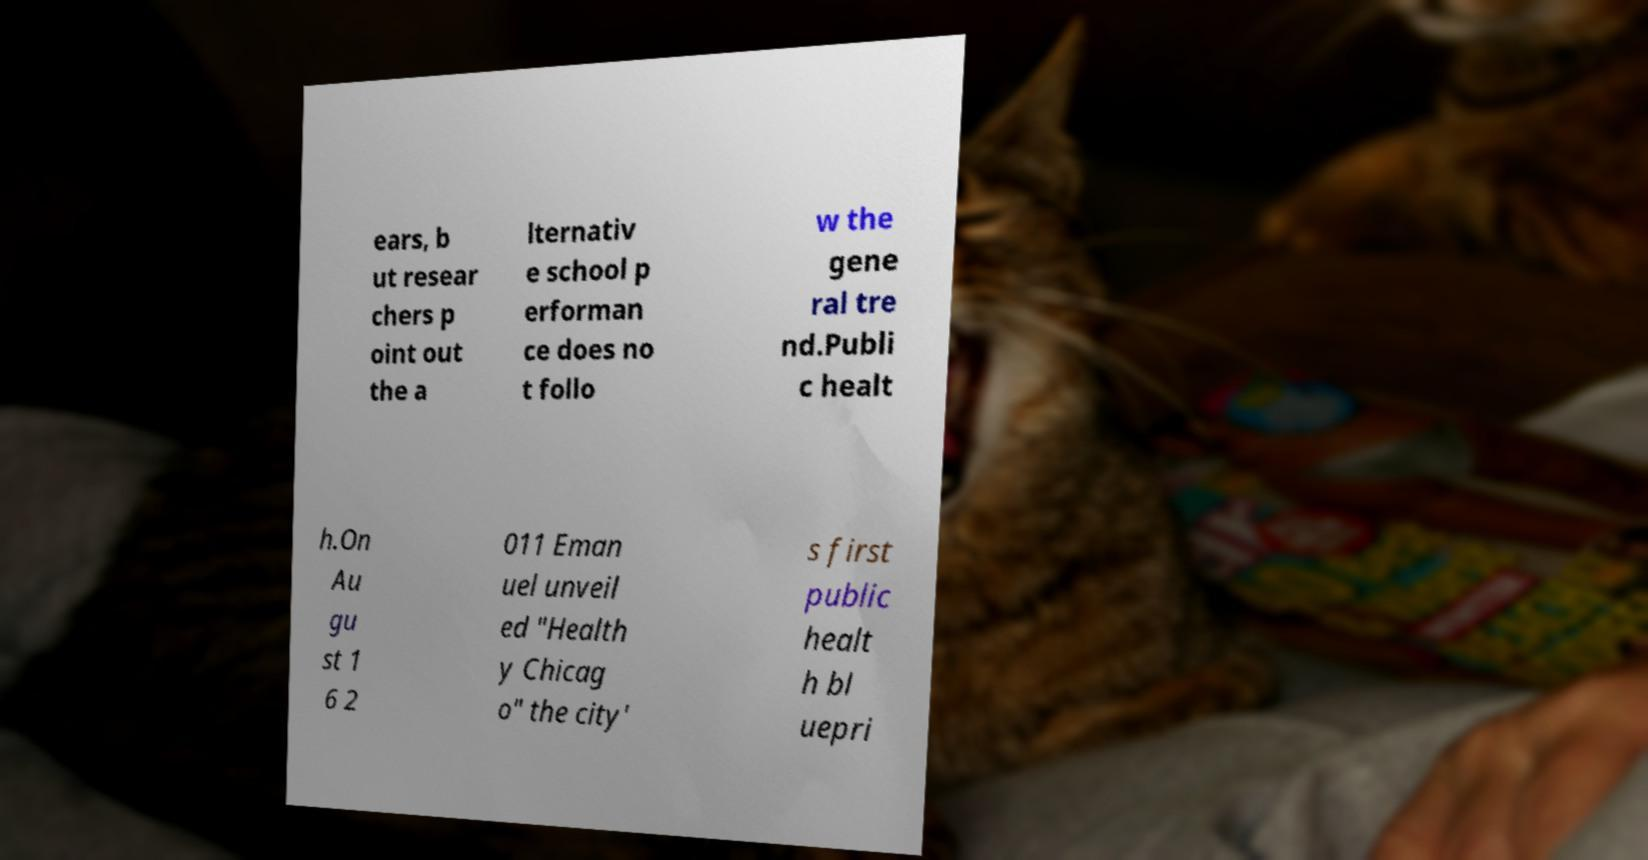Could you assist in decoding the text presented in this image and type it out clearly? ears, b ut resear chers p oint out the a lternativ e school p erforman ce does no t follo w the gene ral tre nd.Publi c healt h.On Au gu st 1 6 2 011 Eman uel unveil ed "Health y Chicag o" the city' s first public healt h bl uepri 